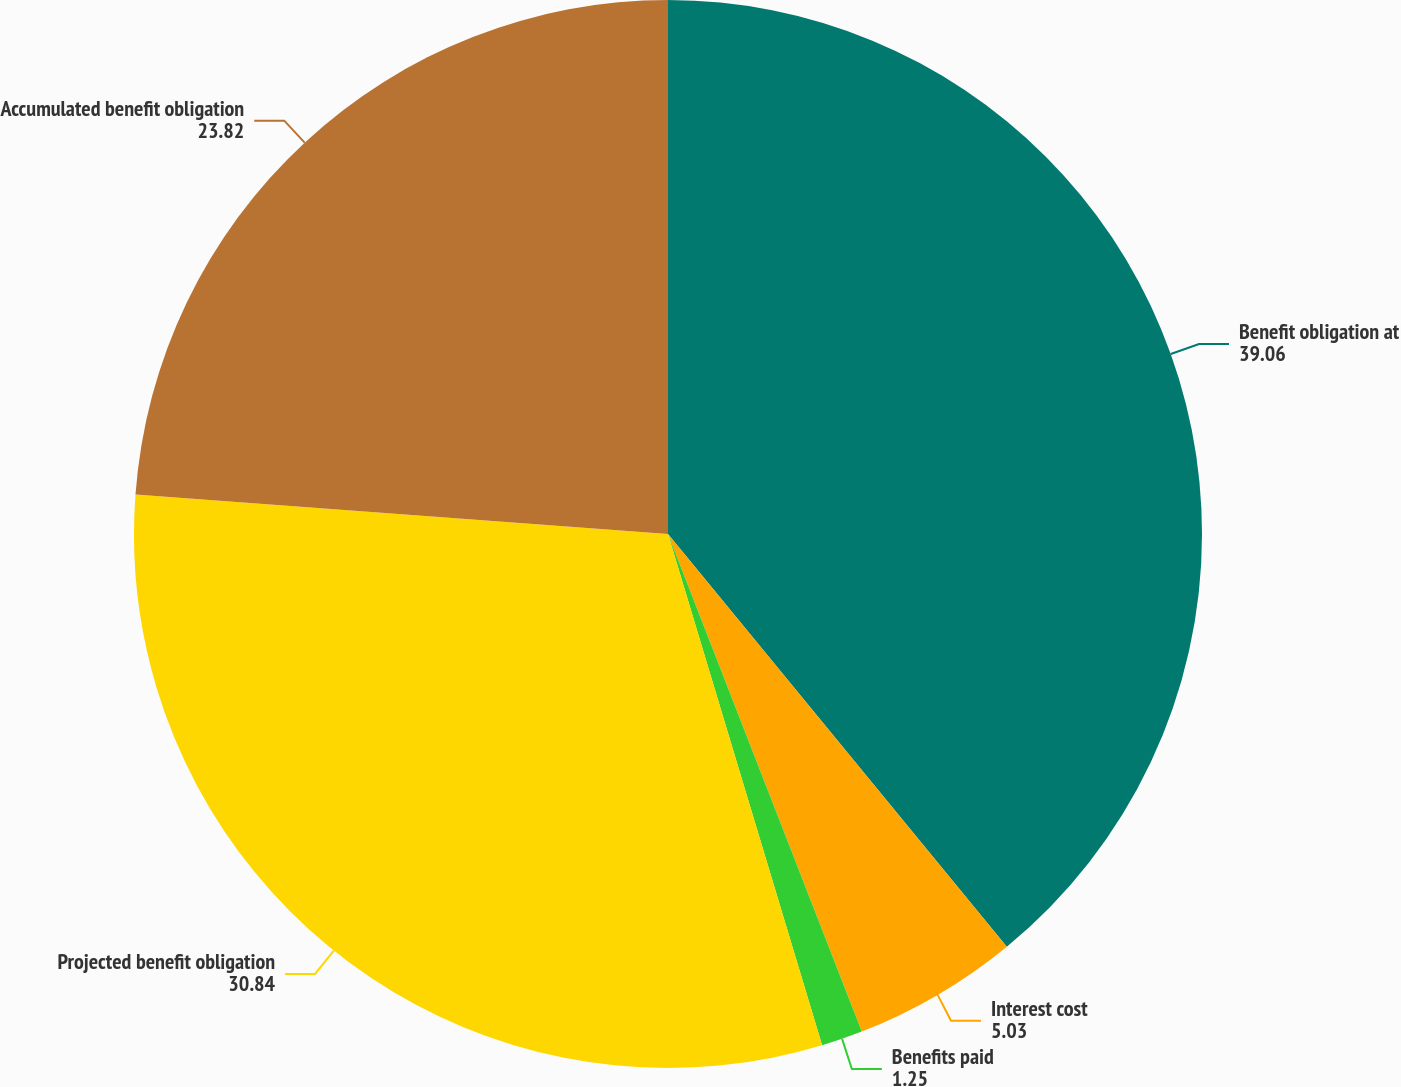Convert chart. <chart><loc_0><loc_0><loc_500><loc_500><pie_chart><fcel>Benefit obligation at<fcel>Interest cost<fcel>Benefits paid<fcel>Projected benefit obligation<fcel>Accumulated benefit obligation<nl><fcel>39.06%<fcel>5.03%<fcel>1.25%<fcel>30.84%<fcel>23.82%<nl></chart> 